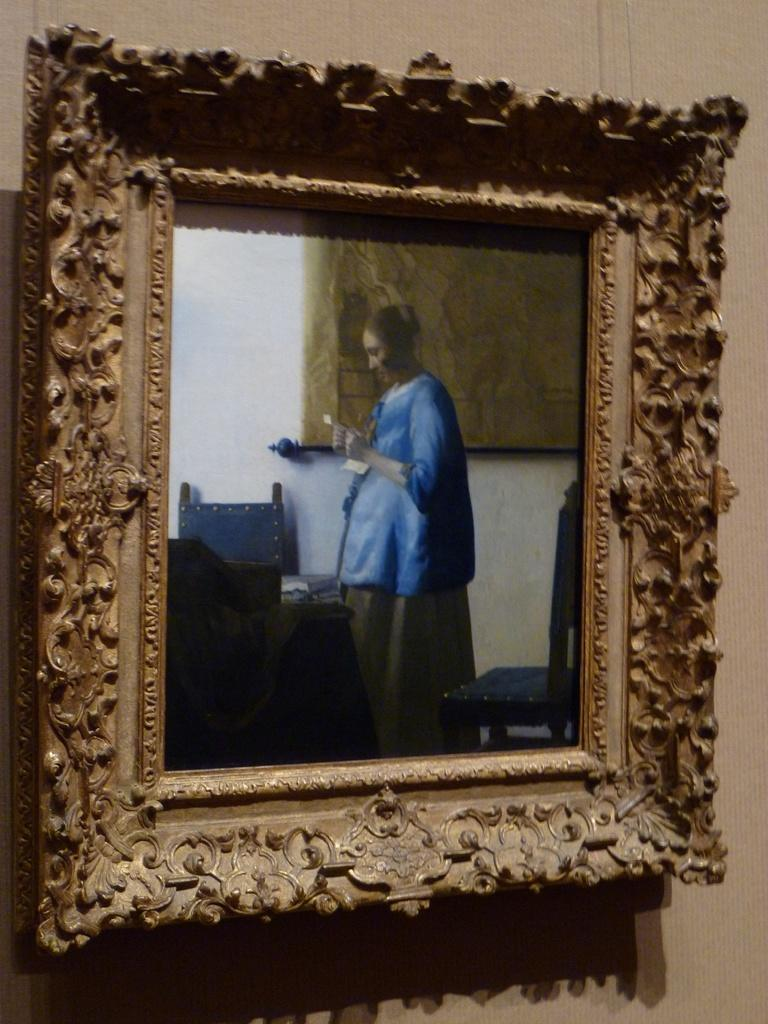What is hanging on the wall in the image? There is a photo frame on the wall. What is depicted in the photo frame? The photo frame contains an image of a woman standing. What type of furniture is placed on the ground in the image? There are chairs and a table placed on the ground. Where is the toothpaste placed in the image? There is no toothpaste present in the image. What type of cap is visible on the woman's head in the photo frame? The image in the photo frame does not show the woman wearing a cap. 